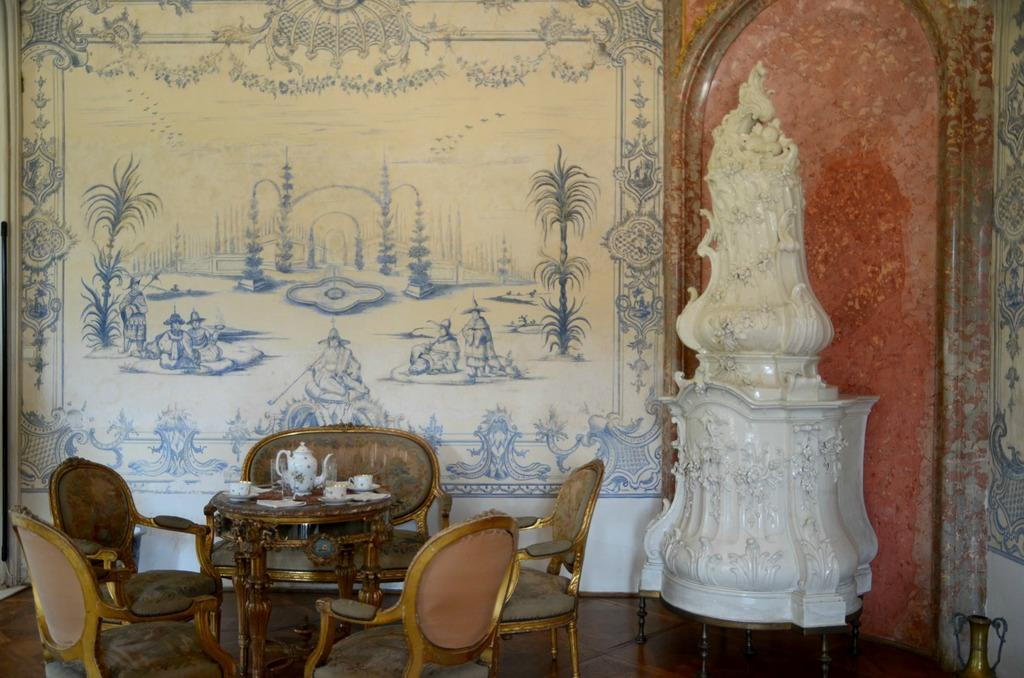What is the main subject in the foreground of the image? There is a stone sculpture in the foreground of the image. What type of furniture can be seen in the image? There are chairs and a table in the image. What is on the table in the image? There are cups, a jar, and additional objects on the table. What is visible in the background of the image? There is a wall in the background of the image. What letter is written on the lace in the image? There is no lace or letter present in the image. What is the price of the stone sculpture in the image? The price of the stone sculpture is not mentioned in the image. 